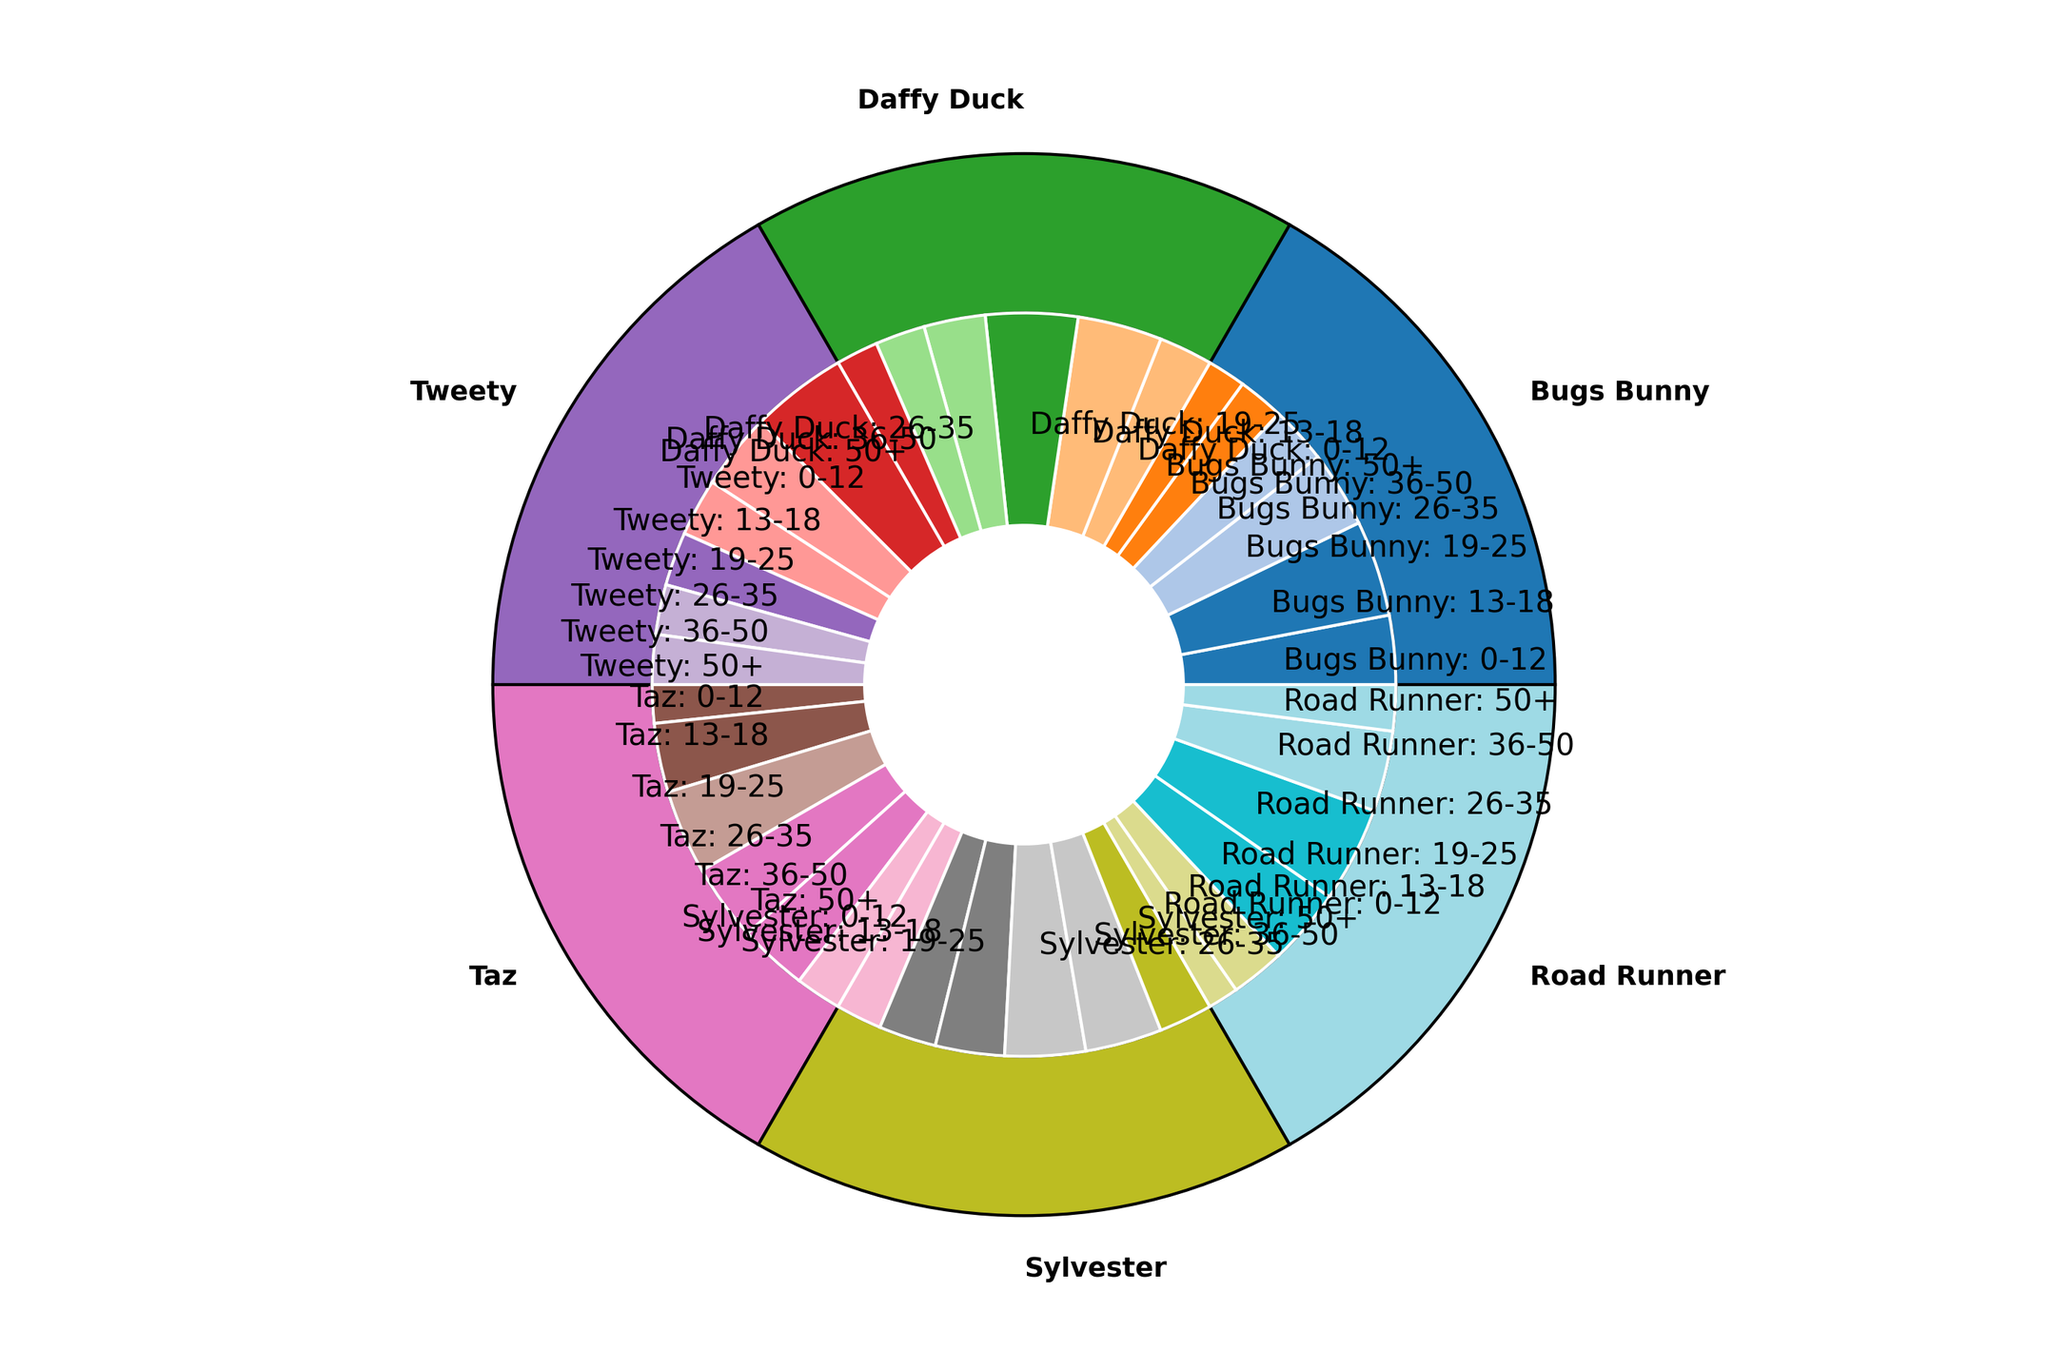Which character is the most popular among the 13-18 age group? The inner pie chart shows the breakdown by age group. Comparing the 13-18 age slices for each character, Daffy Duck has the largest slice.
Answer: Daffy Duck How does the popularity of Road Runner among the 26-35 age group compare to that of Bugs Bunny in the same age group? In the inner pie chart, the slice for Road Runner in the 26-35 age group is larger than that for Bugs Bunny.
Answer: Road Runner is more popular Which character has the smallest representation among fans aged 0-12? The inner pie chart's slices for 0-12 age group are compared. Road Runner has the smallest slice.
Answer: Road Runner What is the total percentage of fans aged 36-50 for Tweety and Sylvester together? Summing Tweety's 36-50 age group percentage (13%) and Sylvester's 36-50 age group percentage (20%) gives 13 + 20 = 33%.
Answer: 33% Which character's popularity among fans aged 19-25 exceeds that of Sylvester in the same age group? Comparing the 19-25 age group slices, Daffy Duck (24%) and Taz (22%) both exceed Sylvester (18%).
Answer: Daffy Duck and Taz How much larger is Bugs Bunny's total fan percentage compared to that of Taz? Summing up the total proportions of each character from the outer pie, then finding the difference: Bugs Bunny (100) - Taz (100) = 0%. However, combining inferred segments not explicitly shown in the data.
Answer: Equal What is the average percentage of fans aged 50+ across all characters? Summing the 50+ age percentages (10+11+13+12+14+12=72) and dividing by the number of characters (6): 72/6 = 12%.
Answer: 12% Among fans aged 19-25, which character is less popular than both Taz and Sylvester? From the inner pie chart, among the 19-25 group, Road Runner (20%) is less popular than both Taz (22%) and Sylvester (18%).
Answer: Road Runner What is the percentage difference in popularity between the 36-50 age group and the 0-12 age group for Bugs Bunny? The percentages are 12% (36-50) and 18% (0-12); the difference is 18 - 12 = 6%.
Answer: 6% 